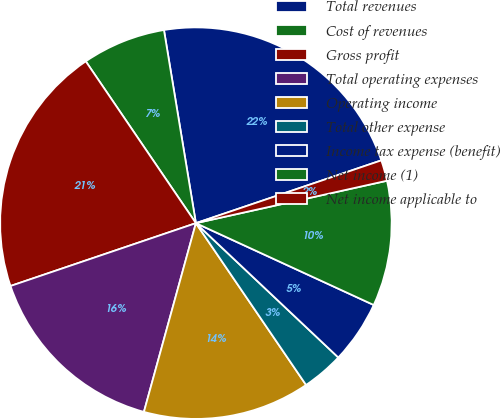<chart> <loc_0><loc_0><loc_500><loc_500><pie_chart><fcel>Total revenues<fcel>Cost of revenues<fcel>Gross profit<fcel>Total operating expenses<fcel>Operating income<fcel>Total other expense<fcel>Income tax expense (benefit)<fcel>Net income (1)<fcel>Net income applicable to<nl><fcel>22.41%<fcel>6.9%<fcel>20.69%<fcel>15.52%<fcel>13.79%<fcel>3.45%<fcel>5.17%<fcel>10.34%<fcel>1.72%<nl></chart> 